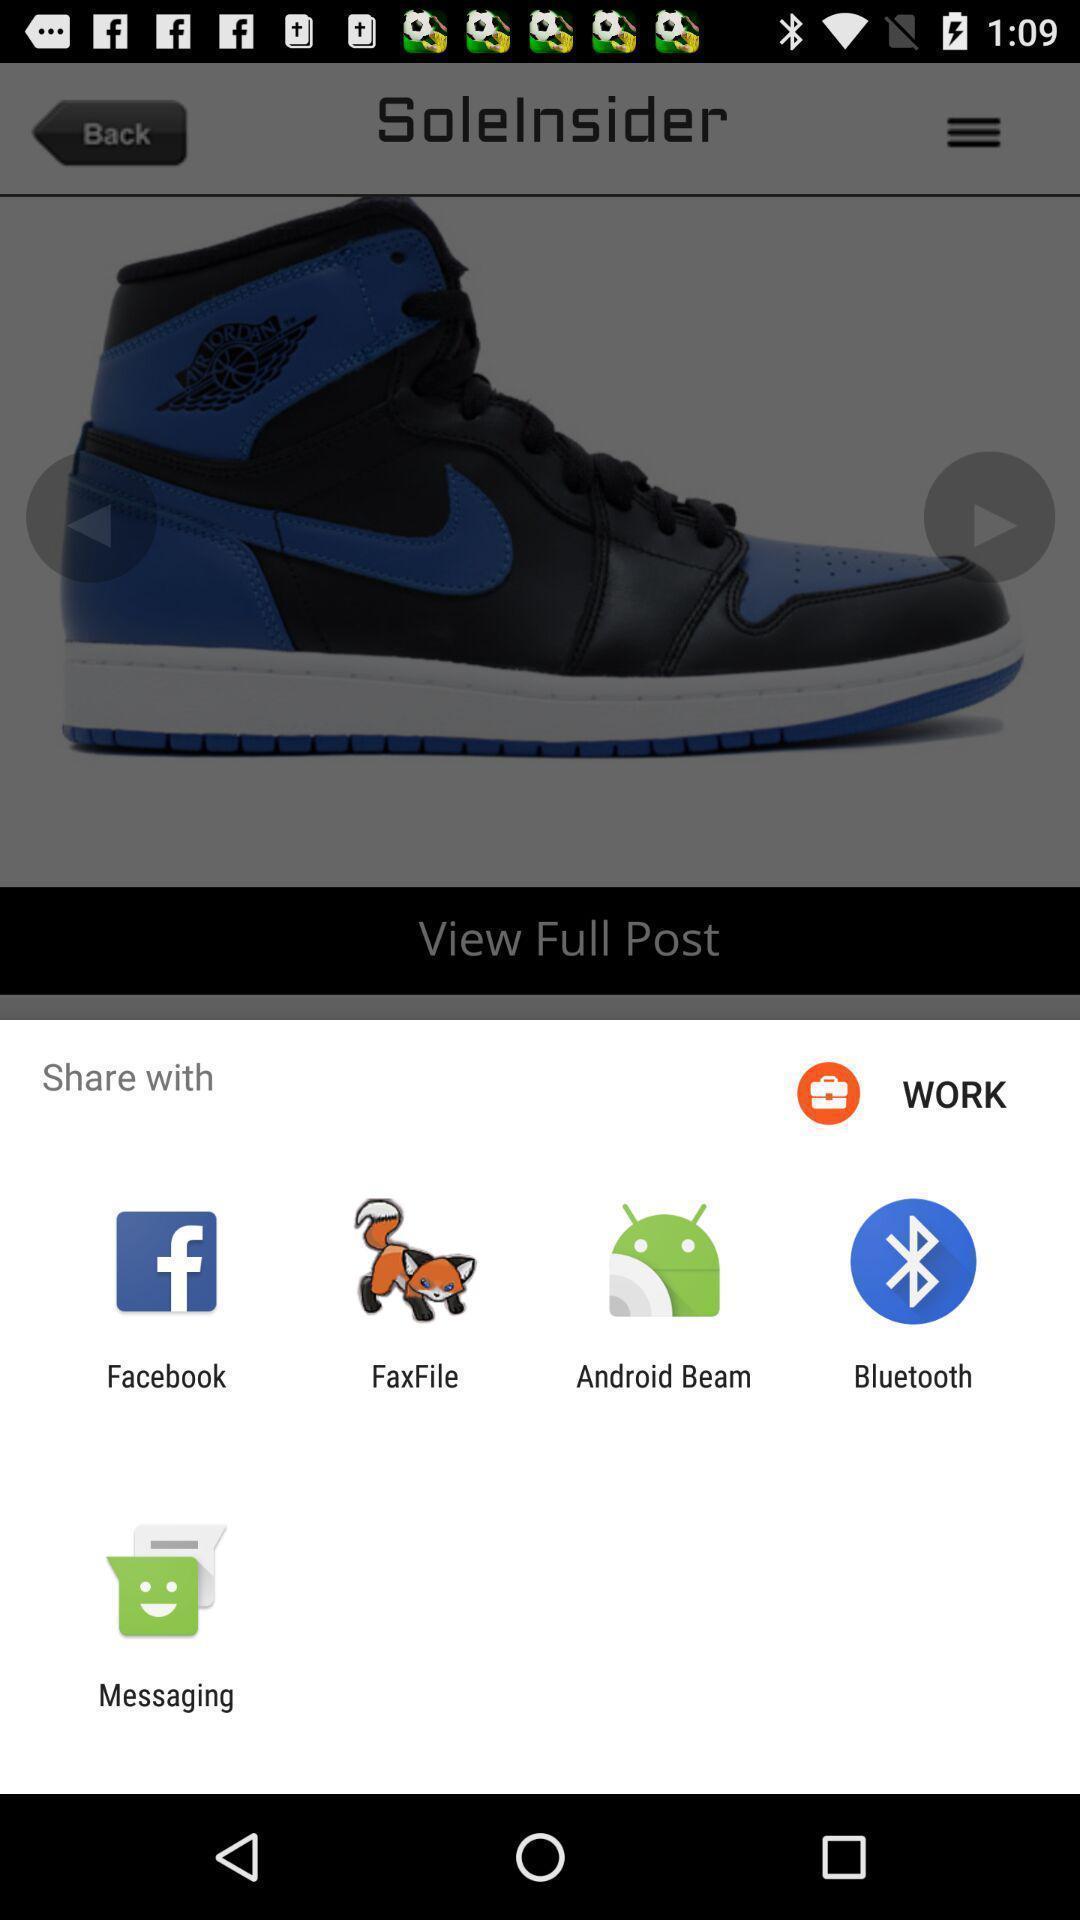Describe the key features of this screenshot. Widget showing multiple sharing apps. 